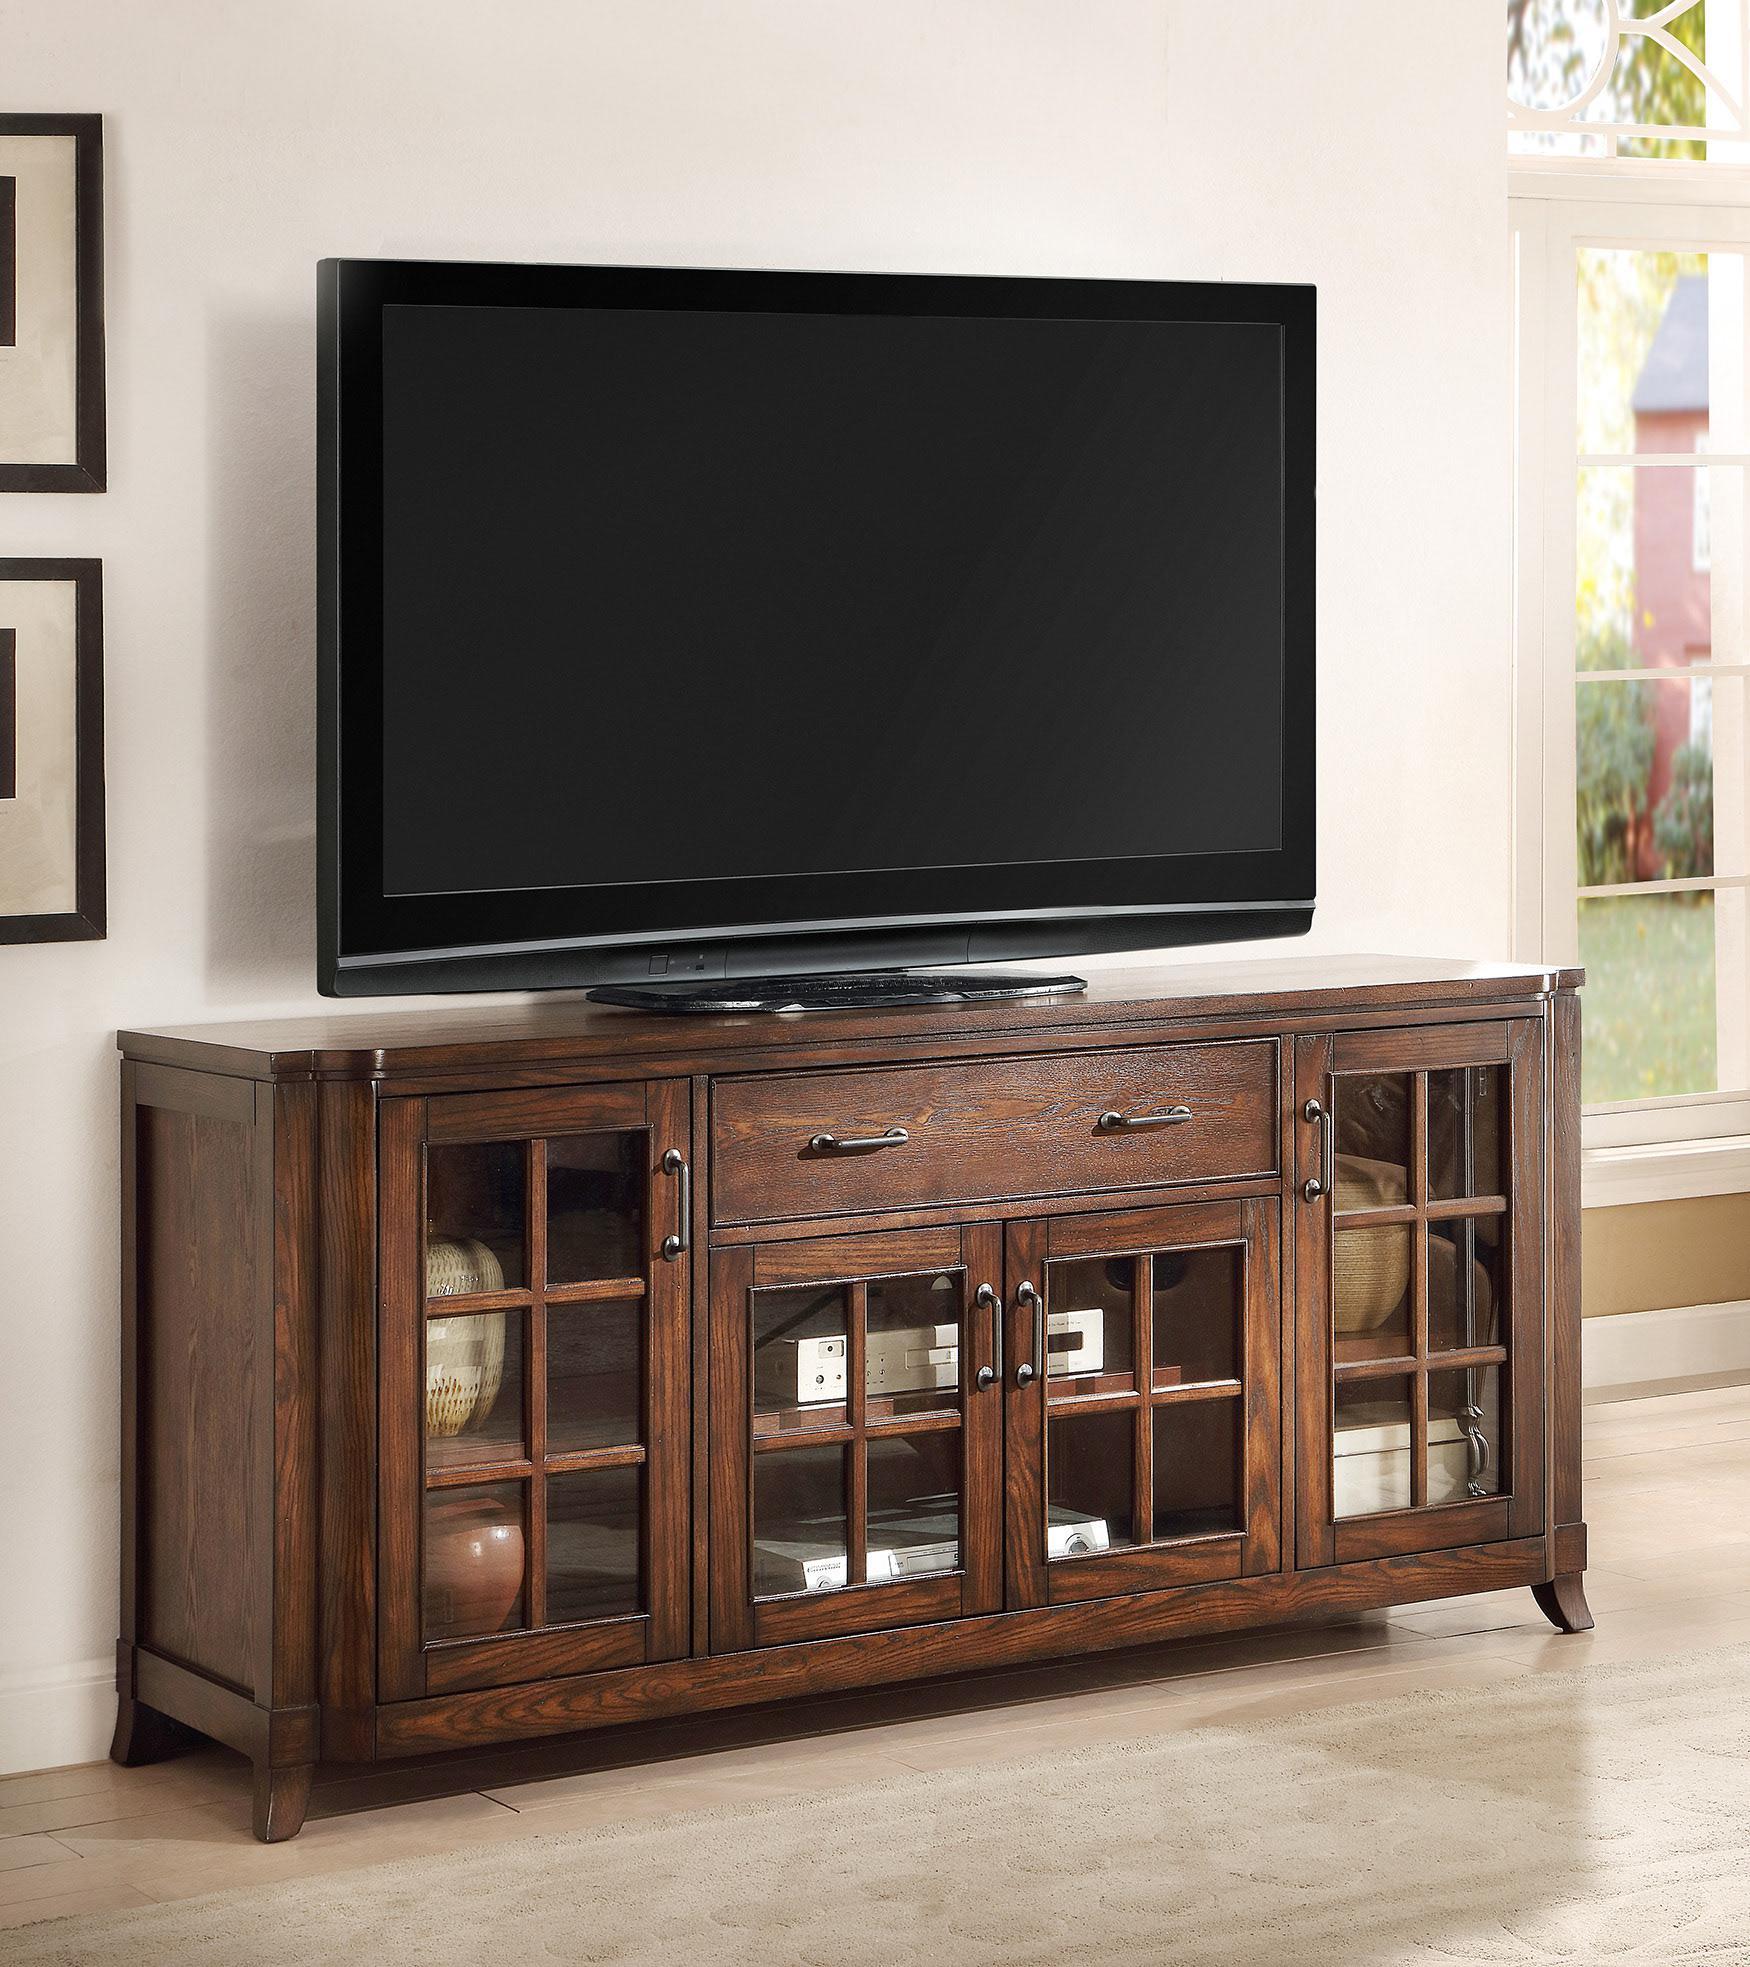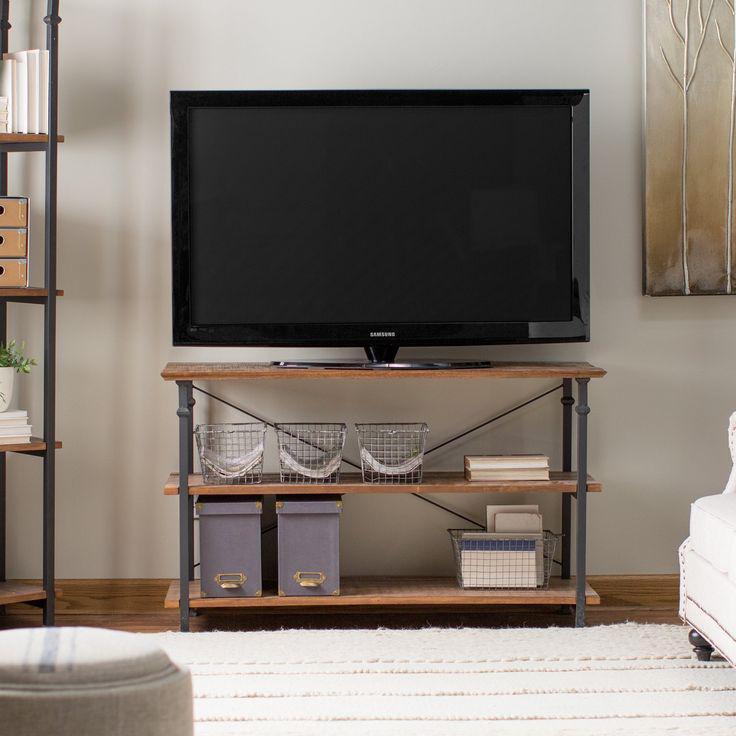The first image is the image on the left, the second image is the image on the right. Given the left and right images, does the statement "The TV stands on the left and right are similar styles, with the same dark wood and approximately the same configuration of compartments." hold true? Answer yes or no. No. The first image is the image on the left, the second image is the image on the right. Assess this claim about the two images: "A flat screen television is sitting against a wall on a low wooden cabinet that has four glass-fronted doors.". Correct or not? Answer yes or no. Yes. 